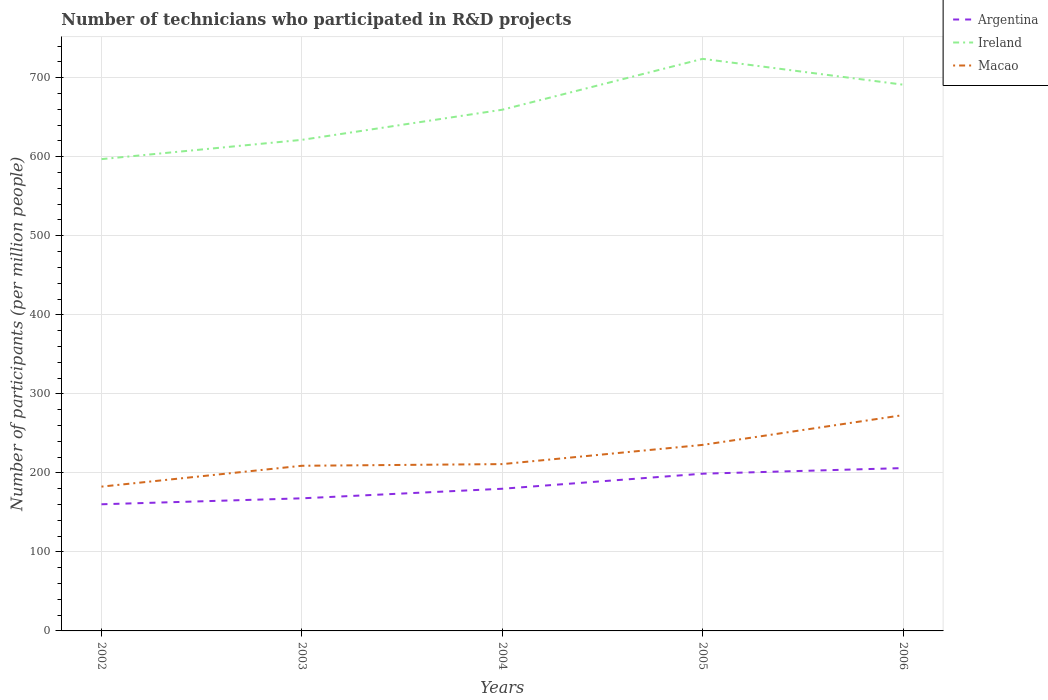How many different coloured lines are there?
Ensure brevity in your answer.  3. Is the number of lines equal to the number of legend labels?
Your answer should be very brief. Yes. Across all years, what is the maximum number of technicians who participated in R&D projects in Argentina?
Make the answer very short. 160.26. What is the total number of technicians who participated in R&D projects in Ireland in the graph?
Your answer should be compact. -38.12. What is the difference between the highest and the second highest number of technicians who participated in R&D projects in Macao?
Provide a short and direct response. 90.49. What is the title of the graph?
Give a very brief answer. Number of technicians who participated in R&D projects. What is the label or title of the Y-axis?
Offer a very short reply. Number of participants (per million people). What is the Number of participants (per million people) of Argentina in 2002?
Ensure brevity in your answer.  160.26. What is the Number of participants (per million people) in Ireland in 2002?
Your response must be concise. 596.99. What is the Number of participants (per million people) of Macao in 2002?
Your answer should be compact. 182.58. What is the Number of participants (per million people) of Argentina in 2003?
Offer a very short reply. 167.79. What is the Number of participants (per million people) of Ireland in 2003?
Your answer should be compact. 621.38. What is the Number of participants (per million people) of Macao in 2003?
Make the answer very short. 208.98. What is the Number of participants (per million people) in Argentina in 2004?
Offer a terse response. 179.89. What is the Number of participants (per million people) in Ireland in 2004?
Provide a short and direct response. 659.5. What is the Number of participants (per million people) of Macao in 2004?
Your answer should be very brief. 211.09. What is the Number of participants (per million people) in Argentina in 2005?
Give a very brief answer. 198.95. What is the Number of participants (per million people) of Ireland in 2005?
Offer a very short reply. 723.89. What is the Number of participants (per million people) in Macao in 2005?
Make the answer very short. 235.4. What is the Number of participants (per million people) in Argentina in 2006?
Give a very brief answer. 206.05. What is the Number of participants (per million people) of Ireland in 2006?
Your response must be concise. 691.21. What is the Number of participants (per million people) of Macao in 2006?
Provide a succinct answer. 273.07. Across all years, what is the maximum Number of participants (per million people) of Argentina?
Keep it short and to the point. 206.05. Across all years, what is the maximum Number of participants (per million people) of Ireland?
Your response must be concise. 723.89. Across all years, what is the maximum Number of participants (per million people) in Macao?
Give a very brief answer. 273.07. Across all years, what is the minimum Number of participants (per million people) in Argentina?
Your response must be concise. 160.26. Across all years, what is the minimum Number of participants (per million people) in Ireland?
Give a very brief answer. 596.99. Across all years, what is the minimum Number of participants (per million people) in Macao?
Your response must be concise. 182.58. What is the total Number of participants (per million people) in Argentina in the graph?
Offer a very short reply. 912.94. What is the total Number of participants (per million people) of Ireland in the graph?
Keep it short and to the point. 3292.97. What is the total Number of participants (per million people) in Macao in the graph?
Give a very brief answer. 1111.12. What is the difference between the Number of participants (per million people) in Argentina in 2002 and that in 2003?
Offer a very short reply. -7.54. What is the difference between the Number of participants (per million people) of Ireland in 2002 and that in 2003?
Offer a terse response. -24.39. What is the difference between the Number of participants (per million people) in Macao in 2002 and that in 2003?
Your answer should be very brief. -26.4. What is the difference between the Number of participants (per million people) in Argentina in 2002 and that in 2004?
Keep it short and to the point. -19.64. What is the difference between the Number of participants (per million people) in Ireland in 2002 and that in 2004?
Provide a short and direct response. -62.51. What is the difference between the Number of participants (per million people) of Macao in 2002 and that in 2004?
Offer a very short reply. -28.5. What is the difference between the Number of participants (per million people) of Argentina in 2002 and that in 2005?
Make the answer very short. -38.69. What is the difference between the Number of participants (per million people) in Ireland in 2002 and that in 2005?
Make the answer very short. -126.89. What is the difference between the Number of participants (per million people) in Macao in 2002 and that in 2005?
Keep it short and to the point. -52.81. What is the difference between the Number of participants (per million people) of Argentina in 2002 and that in 2006?
Your answer should be very brief. -45.79. What is the difference between the Number of participants (per million people) of Ireland in 2002 and that in 2006?
Provide a succinct answer. -94.21. What is the difference between the Number of participants (per million people) of Macao in 2002 and that in 2006?
Your response must be concise. -90.49. What is the difference between the Number of participants (per million people) of Argentina in 2003 and that in 2004?
Offer a terse response. -12.1. What is the difference between the Number of participants (per million people) of Ireland in 2003 and that in 2004?
Your answer should be very brief. -38.12. What is the difference between the Number of participants (per million people) in Macao in 2003 and that in 2004?
Keep it short and to the point. -2.1. What is the difference between the Number of participants (per million people) of Argentina in 2003 and that in 2005?
Provide a short and direct response. -31.16. What is the difference between the Number of participants (per million people) of Ireland in 2003 and that in 2005?
Make the answer very short. -102.5. What is the difference between the Number of participants (per million people) in Macao in 2003 and that in 2005?
Your answer should be very brief. -26.41. What is the difference between the Number of participants (per million people) of Argentina in 2003 and that in 2006?
Your answer should be compact. -38.26. What is the difference between the Number of participants (per million people) of Ireland in 2003 and that in 2006?
Ensure brevity in your answer.  -69.82. What is the difference between the Number of participants (per million people) in Macao in 2003 and that in 2006?
Offer a terse response. -64.09. What is the difference between the Number of participants (per million people) of Argentina in 2004 and that in 2005?
Provide a short and direct response. -19.06. What is the difference between the Number of participants (per million people) of Ireland in 2004 and that in 2005?
Provide a succinct answer. -64.38. What is the difference between the Number of participants (per million people) in Macao in 2004 and that in 2005?
Offer a very short reply. -24.31. What is the difference between the Number of participants (per million people) in Argentina in 2004 and that in 2006?
Your answer should be compact. -26.16. What is the difference between the Number of participants (per million people) of Ireland in 2004 and that in 2006?
Make the answer very short. -31.7. What is the difference between the Number of participants (per million people) in Macao in 2004 and that in 2006?
Keep it short and to the point. -61.98. What is the difference between the Number of participants (per million people) in Argentina in 2005 and that in 2006?
Your answer should be very brief. -7.1. What is the difference between the Number of participants (per million people) in Ireland in 2005 and that in 2006?
Keep it short and to the point. 32.68. What is the difference between the Number of participants (per million people) of Macao in 2005 and that in 2006?
Provide a succinct answer. -37.68. What is the difference between the Number of participants (per million people) of Argentina in 2002 and the Number of participants (per million people) of Ireland in 2003?
Provide a succinct answer. -461.13. What is the difference between the Number of participants (per million people) in Argentina in 2002 and the Number of participants (per million people) in Macao in 2003?
Your answer should be very brief. -48.73. What is the difference between the Number of participants (per million people) in Ireland in 2002 and the Number of participants (per million people) in Macao in 2003?
Your response must be concise. 388.01. What is the difference between the Number of participants (per million people) of Argentina in 2002 and the Number of participants (per million people) of Ireland in 2004?
Provide a short and direct response. -499.25. What is the difference between the Number of participants (per million people) of Argentina in 2002 and the Number of participants (per million people) of Macao in 2004?
Provide a succinct answer. -50.83. What is the difference between the Number of participants (per million people) of Ireland in 2002 and the Number of participants (per million people) of Macao in 2004?
Offer a terse response. 385.91. What is the difference between the Number of participants (per million people) in Argentina in 2002 and the Number of participants (per million people) in Ireland in 2005?
Offer a terse response. -563.63. What is the difference between the Number of participants (per million people) of Argentina in 2002 and the Number of participants (per million people) of Macao in 2005?
Your response must be concise. -75.14. What is the difference between the Number of participants (per million people) of Ireland in 2002 and the Number of participants (per million people) of Macao in 2005?
Ensure brevity in your answer.  361.6. What is the difference between the Number of participants (per million people) of Argentina in 2002 and the Number of participants (per million people) of Ireland in 2006?
Provide a succinct answer. -530.95. What is the difference between the Number of participants (per million people) in Argentina in 2002 and the Number of participants (per million people) in Macao in 2006?
Your answer should be very brief. -112.82. What is the difference between the Number of participants (per million people) in Ireland in 2002 and the Number of participants (per million people) in Macao in 2006?
Make the answer very short. 323.92. What is the difference between the Number of participants (per million people) of Argentina in 2003 and the Number of participants (per million people) of Ireland in 2004?
Offer a terse response. -491.71. What is the difference between the Number of participants (per million people) in Argentina in 2003 and the Number of participants (per million people) in Macao in 2004?
Your answer should be very brief. -43.3. What is the difference between the Number of participants (per million people) of Ireland in 2003 and the Number of participants (per million people) of Macao in 2004?
Offer a very short reply. 410.3. What is the difference between the Number of participants (per million people) in Argentina in 2003 and the Number of participants (per million people) in Ireland in 2005?
Make the answer very short. -556.09. What is the difference between the Number of participants (per million people) of Argentina in 2003 and the Number of participants (per million people) of Macao in 2005?
Provide a short and direct response. -67.6. What is the difference between the Number of participants (per million people) of Ireland in 2003 and the Number of participants (per million people) of Macao in 2005?
Provide a succinct answer. 385.99. What is the difference between the Number of participants (per million people) of Argentina in 2003 and the Number of participants (per million people) of Ireland in 2006?
Make the answer very short. -523.41. What is the difference between the Number of participants (per million people) in Argentina in 2003 and the Number of participants (per million people) in Macao in 2006?
Give a very brief answer. -105.28. What is the difference between the Number of participants (per million people) of Ireland in 2003 and the Number of participants (per million people) of Macao in 2006?
Offer a very short reply. 348.31. What is the difference between the Number of participants (per million people) of Argentina in 2004 and the Number of participants (per million people) of Ireland in 2005?
Offer a very short reply. -543.99. What is the difference between the Number of participants (per million people) in Argentina in 2004 and the Number of participants (per million people) in Macao in 2005?
Your answer should be very brief. -55.5. What is the difference between the Number of participants (per million people) of Ireland in 2004 and the Number of participants (per million people) of Macao in 2005?
Your response must be concise. 424.11. What is the difference between the Number of participants (per million people) in Argentina in 2004 and the Number of participants (per million people) in Ireland in 2006?
Ensure brevity in your answer.  -511.31. What is the difference between the Number of participants (per million people) of Argentina in 2004 and the Number of participants (per million people) of Macao in 2006?
Offer a terse response. -93.18. What is the difference between the Number of participants (per million people) of Ireland in 2004 and the Number of participants (per million people) of Macao in 2006?
Provide a succinct answer. 386.43. What is the difference between the Number of participants (per million people) of Argentina in 2005 and the Number of participants (per million people) of Ireland in 2006?
Keep it short and to the point. -492.26. What is the difference between the Number of participants (per million people) in Argentina in 2005 and the Number of participants (per million people) in Macao in 2006?
Keep it short and to the point. -74.12. What is the difference between the Number of participants (per million people) of Ireland in 2005 and the Number of participants (per million people) of Macao in 2006?
Make the answer very short. 450.81. What is the average Number of participants (per million people) in Argentina per year?
Your answer should be compact. 182.59. What is the average Number of participants (per million people) of Ireland per year?
Make the answer very short. 658.59. What is the average Number of participants (per million people) in Macao per year?
Offer a very short reply. 222.22. In the year 2002, what is the difference between the Number of participants (per million people) of Argentina and Number of participants (per million people) of Ireland?
Make the answer very short. -436.74. In the year 2002, what is the difference between the Number of participants (per million people) of Argentina and Number of participants (per million people) of Macao?
Your answer should be very brief. -22.33. In the year 2002, what is the difference between the Number of participants (per million people) in Ireland and Number of participants (per million people) in Macao?
Make the answer very short. 414.41. In the year 2003, what is the difference between the Number of participants (per million people) of Argentina and Number of participants (per million people) of Ireland?
Give a very brief answer. -453.59. In the year 2003, what is the difference between the Number of participants (per million people) in Argentina and Number of participants (per million people) in Macao?
Ensure brevity in your answer.  -41.19. In the year 2003, what is the difference between the Number of participants (per million people) in Ireland and Number of participants (per million people) in Macao?
Make the answer very short. 412.4. In the year 2004, what is the difference between the Number of participants (per million people) in Argentina and Number of participants (per million people) in Ireland?
Give a very brief answer. -479.61. In the year 2004, what is the difference between the Number of participants (per million people) of Argentina and Number of participants (per million people) of Macao?
Make the answer very short. -31.19. In the year 2004, what is the difference between the Number of participants (per million people) in Ireland and Number of participants (per million people) in Macao?
Make the answer very short. 448.42. In the year 2005, what is the difference between the Number of participants (per million people) of Argentina and Number of participants (per million people) of Ireland?
Your answer should be compact. -524.94. In the year 2005, what is the difference between the Number of participants (per million people) of Argentina and Number of participants (per million people) of Macao?
Your answer should be compact. -36.45. In the year 2005, what is the difference between the Number of participants (per million people) of Ireland and Number of participants (per million people) of Macao?
Provide a short and direct response. 488.49. In the year 2006, what is the difference between the Number of participants (per million people) of Argentina and Number of participants (per million people) of Ireland?
Make the answer very short. -485.16. In the year 2006, what is the difference between the Number of participants (per million people) in Argentina and Number of participants (per million people) in Macao?
Offer a very short reply. -67.02. In the year 2006, what is the difference between the Number of participants (per million people) in Ireland and Number of participants (per million people) in Macao?
Provide a succinct answer. 418.13. What is the ratio of the Number of participants (per million people) in Argentina in 2002 to that in 2003?
Your answer should be compact. 0.96. What is the ratio of the Number of participants (per million people) of Ireland in 2002 to that in 2003?
Offer a very short reply. 0.96. What is the ratio of the Number of participants (per million people) in Macao in 2002 to that in 2003?
Your response must be concise. 0.87. What is the ratio of the Number of participants (per million people) of Argentina in 2002 to that in 2004?
Ensure brevity in your answer.  0.89. What is the ratio of the Number of participants (per million people) of Ireland in 2002 to that in 2004?
Ensure brevity in your answer.  0.91. What is the ratio of the Number of participants (per million people) of Macao in 2002 to that in 2004?
Ensure brevity in your answer.  0.86. What is the ratio of the Number of participants (per million people) of Argentina in 2002 to that in 2005?
Your response must be concise. 0.81. What is the ratio of the Number of participants (per million people) in Ireland in 2002 to that in 2005?
Provide a short and direct response. 0.82. What is the ratio of the Number of participants (per million people) in Macao in 2002 to that in 2005?
Ensure brevity in your answer.  0.78. What is the ratio of the Number of participants (per million people) of Ireland in 2002 to that in 2006?
Ensure brevity in your answer.  0.86. What is the ratio of the Number of participants (per million people) in Macao in 2002 to that in 2006?
Ensure brevity in your answer.  0.67. What is the ratio of the Number of participants (per million people) of Argentina in 2003 to that in 2004?
Provide a succinct answer. 0.93. What is the ratio of the Number of participants (per million people) in Ireland in 2003 to that in 2004?
Offer a very short reply. 0.94. What is the ratio of the Number of participants (per million people) of Argentina in 2003 to that in 2005?
Your answer should be very brief. 0.84. What is the ratio of the Number of participants (per million people) in Ireland in 2003 to that in 2005?
Offer a very short reply. 0.86. What is the ratio of the Number of participants (per million people) in Macao in 2003 to that in 2005?
Your response must be concise. 0.89. What is the ratio of the Number of participants (per million people) in Argentina in 2003 to that in 2006?
Provide a short and direct response. 0.81. What is the ratio of the Number of participants (per million people) in Ireland in 2003 to that in 2006?
Provide a succinct answer. 0.9. What is the ratio of the Number of participants (per million people) in Macao in 2003 to that in 2006?
Give a very brief answer. 0.77. What is the ratio of the Number of participants (per million people) of Argentina in 2004 to that in 2005?
Ensure brevity in your answer.  0.9. What is the ratio of the Number of participants (per million people) in Ireland in 2004 to that in 2005?
Offer a very short reply. 0.91. What is the ratio of the Number of participants (per million people) of Macao in 2004 to that in 2005?
Offer a terse response. 0.9. What is the ratio of the Number of participants (per million people) in Argentina in 2004 to that in 2006?
Your answer should be very brief. 0.87. What is the ratio of the Number of participants (per million people) of Ireland in 2004 to that in 2006?
Provide a succinct answer. 0.95. What is the ratio of the Number of participants (per million people) of Macao in 2004 to that in 2006?
Your answer should be compact. 0.77. What is the ratio of the Number of participants (per million people) of Argentina in 2005 to that in 2006?
Make the answer very short. 0.97. What is the ratio of the Number of participants (per million people) in Ireland in 2005 to that in 2006?
Your answer should be compact. 1.05. What is the ratio of the Number of participants (per million people) in Macao in 2005 to that in 2006?
Your response must be concise. 0.86. What is the difference between the highest and the second highest Number of participants (per million people) in Argentina?
Give a very brief answer. 7.1. What is the difference between the highest and the second highest Number of participants (per million people) of Ireland?
Offer a terse response. 32.68. What is the difference between the highest and the second highest Number of participants (per million people) in Macao?
Make the answer very short. 37.68. What is the difference between the highest and the lowest Number of participants (per million people) in Argentina?
Provide a short and direct response. 45.79. What is the difference between the highest and the lowest Number of participants (per million people) in Ireland?
Provide a short and direct response. 126.89. What is the difference between the highest and the lowest Number of participants (per million people) of Macao?
Give a very brief answer. 90.49. 